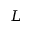Convert formula to latex. <formula><loc_0><loc_0><loc_500><loc_500>L</formula> 